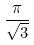Convert formula to latex. <formula><loc_0><loc_0><loc_500><loc_500>\frac { \pi } { \sqrt { 3 } }</formula> 